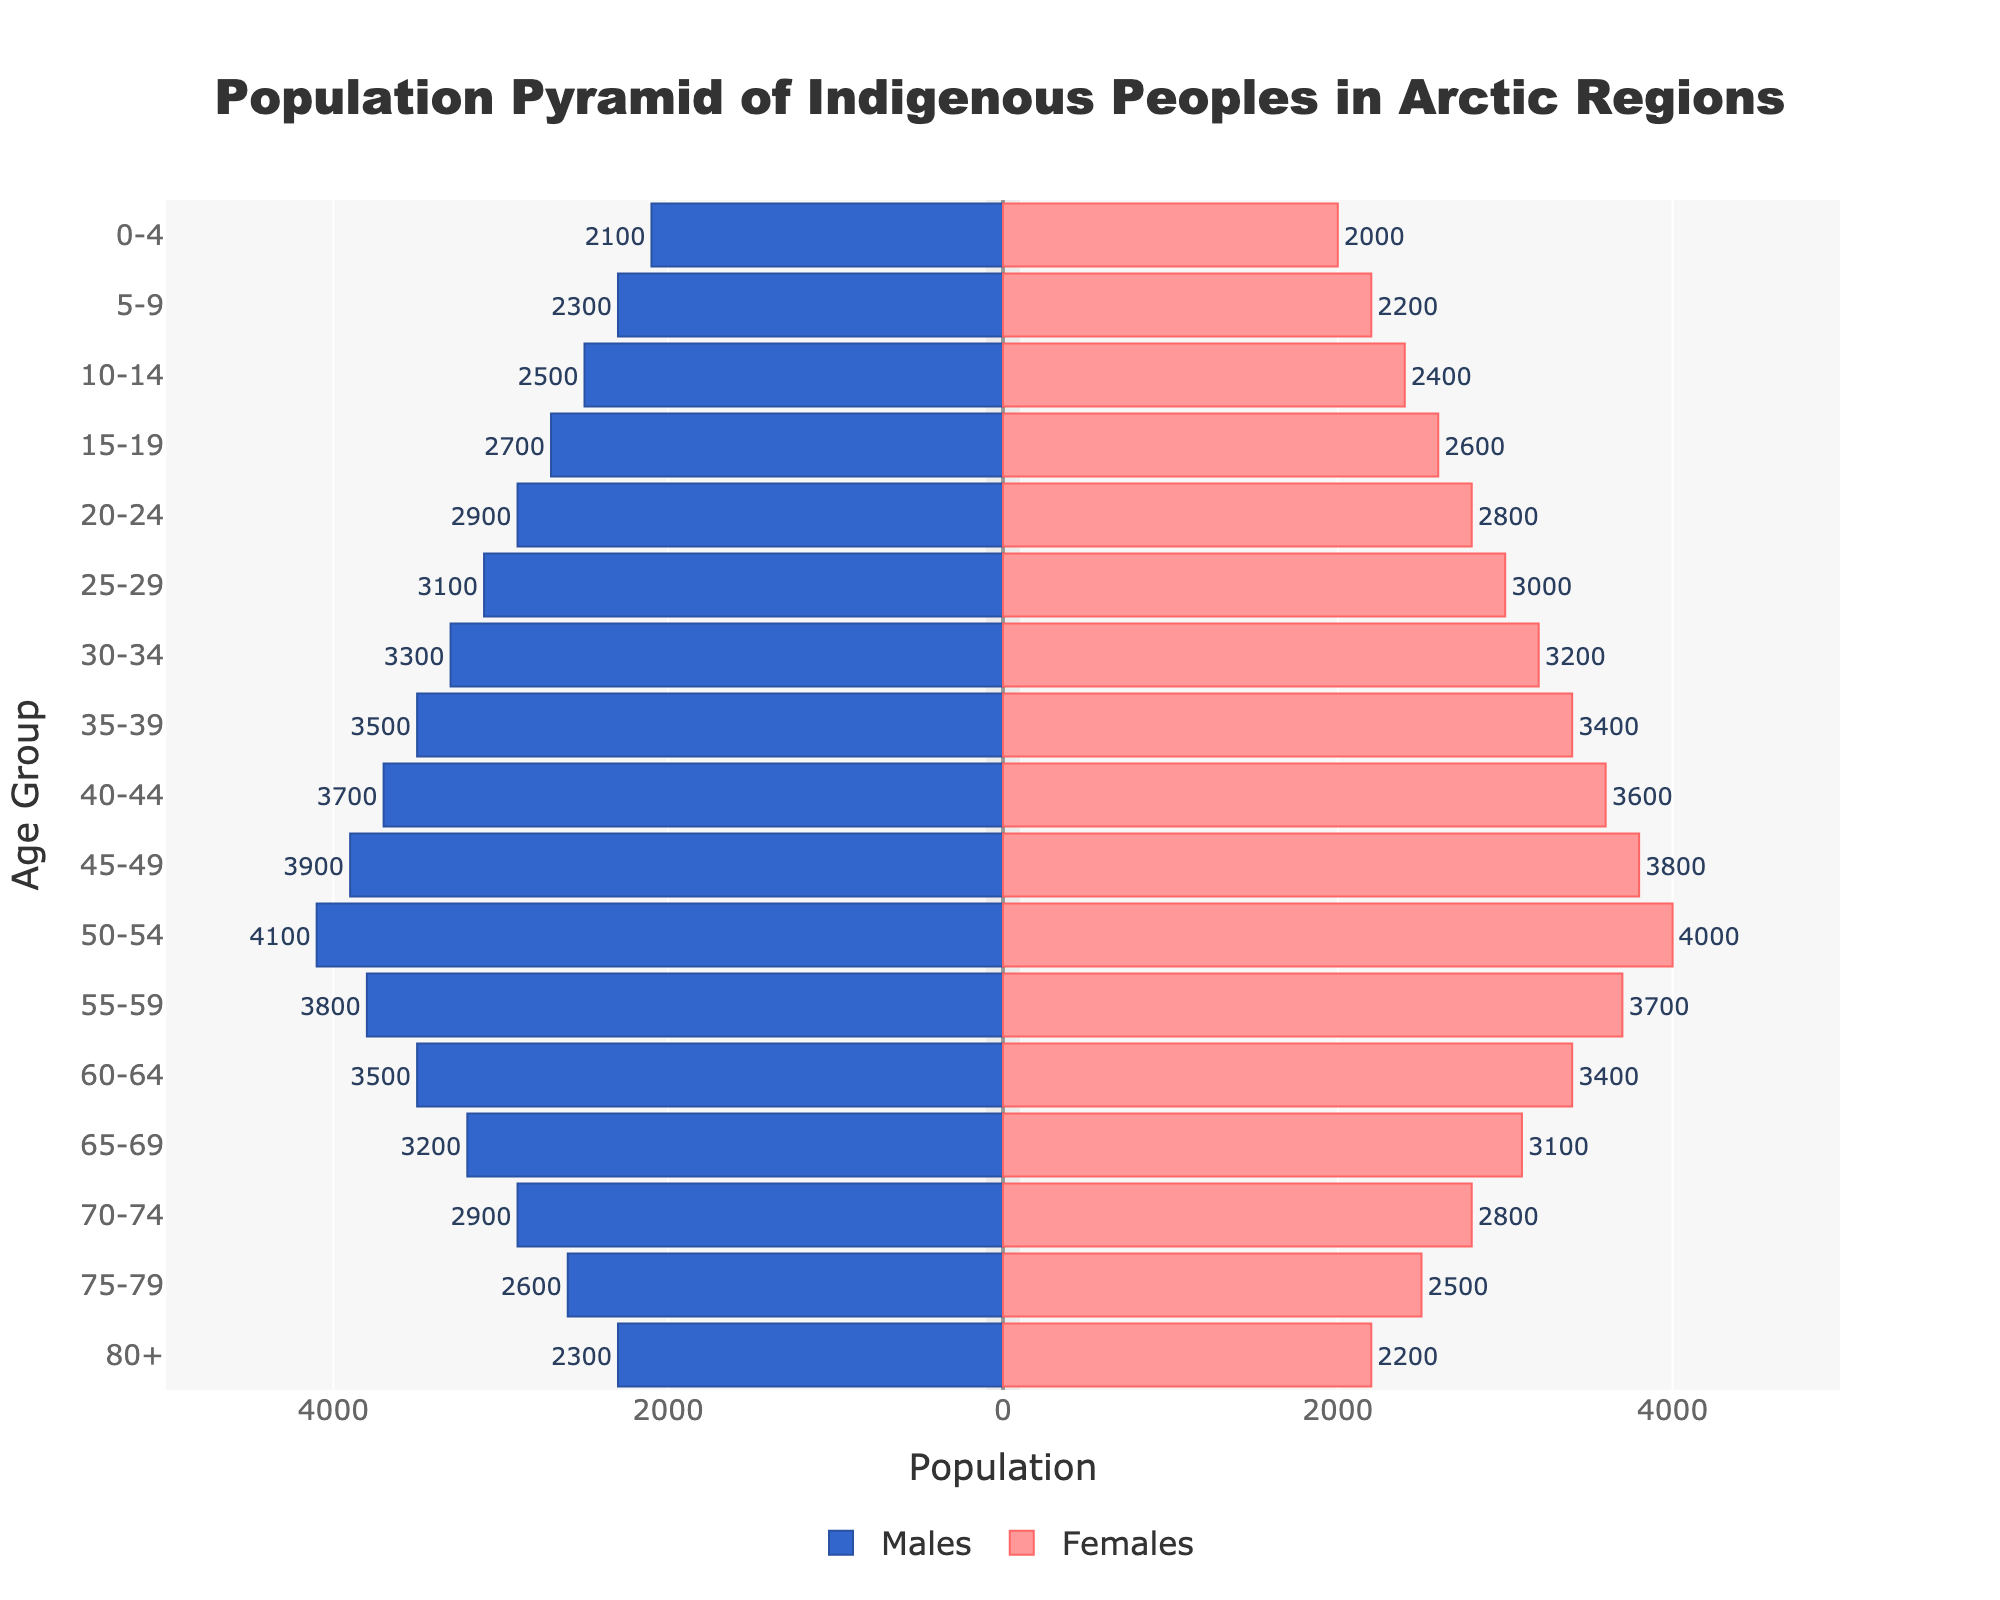What is the title of the figure? The title is usually found at the top of the figure. In this case, it reads "Population Pyramid of Indigenous Peoples in Arctic Regions."
Answer: Population Pyramid of Indigenous Peoples in Arctic Regions How many age groups are represented in the figure? By counting the number of horizontal bars, we see that the age groups represented are 0-4, 5-9, 10-14, 15-19, 20-24, 25-29, 30-34, 35-39, 40-44, 45-49, 50-54, 55-59, 60-64, 65-69, 70-74, 75-79, and 80+, which totals to 17 groups.
Answer: 17 Which age group has the highest population for males? By looking at the bars on the male side (left side), the age group 50-54 has the longest bar, indicating the highest population.
Answer: 50-54 How does the population of females aged 30-34 compare to the population of males in the same age group? The bar for females aged 30-34 is slightly shorter than the bar for males in the same age group. This indicates that the female population is less than the male population.
Answer: Females have a smaller population What is the combined population of males and females in the age group 15-19? The combined population can be obtained by summing the values for males and females in the 15-19 age group: 2700 (males) + 2600 (females) = 5300.
Answer: 5300 Which gender shows a decline in population first as age increases beyond 50 years? Observing the bars beyond the age group 50-54, both male and female populations decline, but the male population shows a visible decline sooner in the 55-59 age group.
Answer: Males What is the total population of individuals aged 75-79? Adding the population figures for both genders in the age group 75-79: 2600 (males) + 2500 (females) = 5100.
Answer: 5100 In which age group is the difference in population between males and females the smallest? The difference can be identified by closely comparing the bars. The age group 0-4 shows the smallest difference, where the male population is 2100 and the female population is 2000, giving a difference of 100.
Answer: 0-4 Is there a clear trend in the gender population as the age increases from 0-80+? The trend shows a steady increase in population for both genders until the age group 50-54. Beyond this age group, the population for both genders decreases, indicating a higher younger population and lower older population.
Answer: Yes, younger age groups have higher populations Which gender has a higher population in the oldest age group (80+)? The bar for females in the 80+ age group is slightly shorter than the bar for males in the same age group. Thus, the male population is higher.
Answer: Males 